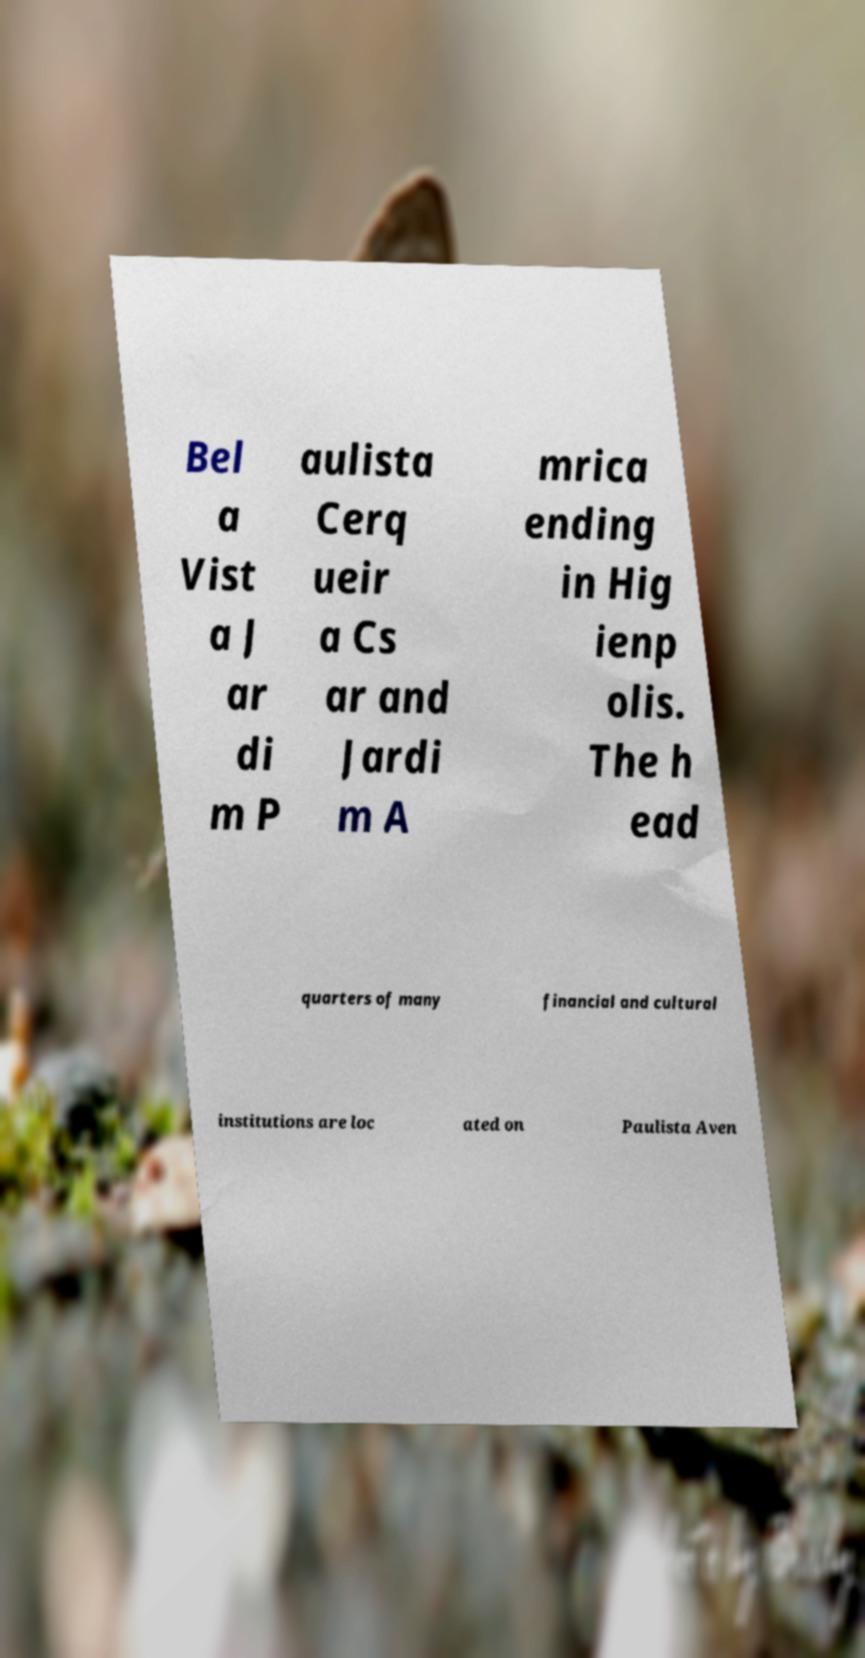Could you extract and type out the text from this image? Bel a Vist a J ar di m P aulista Cerq ueir a Cs ar and Jardi m A mrica ending in Hig ienp olis. The h ead quarters of many financial and cultural institutions are loc ated on Paulista Aven 